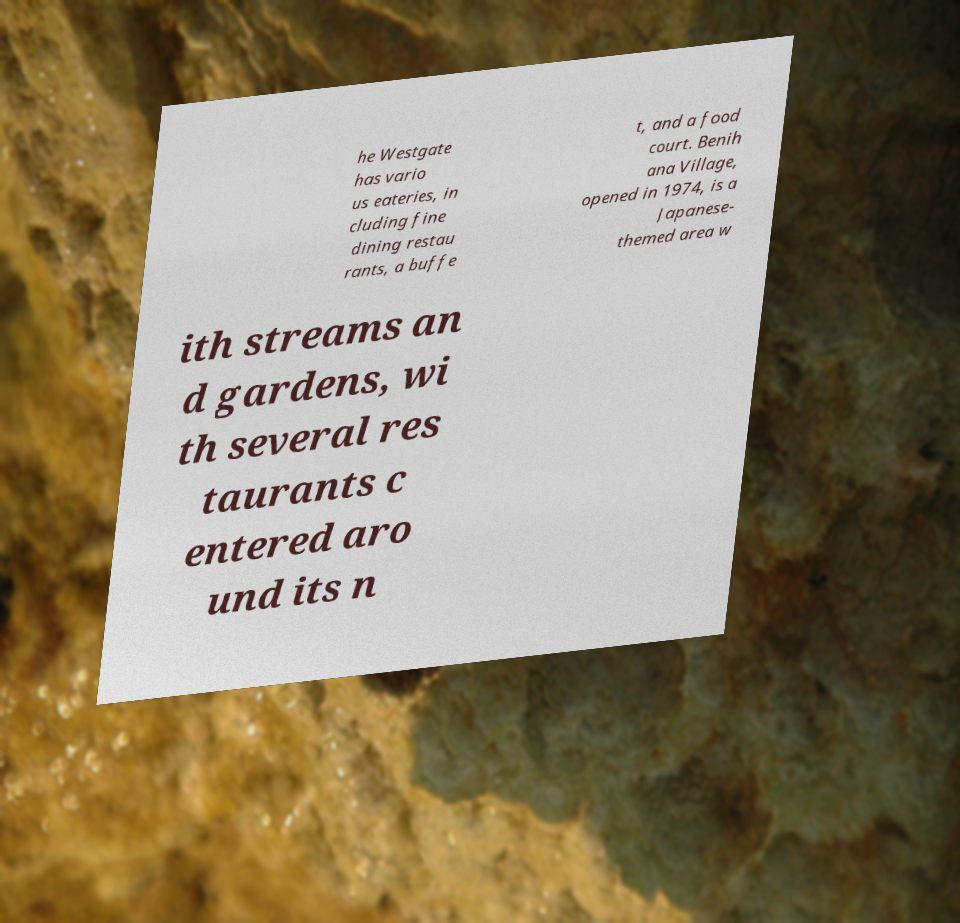I need the written content from this picture converted into text. Can you do that? he Westgate has vario us eateries, in cluding fine dining restau rants, a buffe t, and a food court. Benih ana Village, opened in 1974, is a Japanese- themed area w ith streams an d gardens, wi th several res taurants c entered aro und its n 